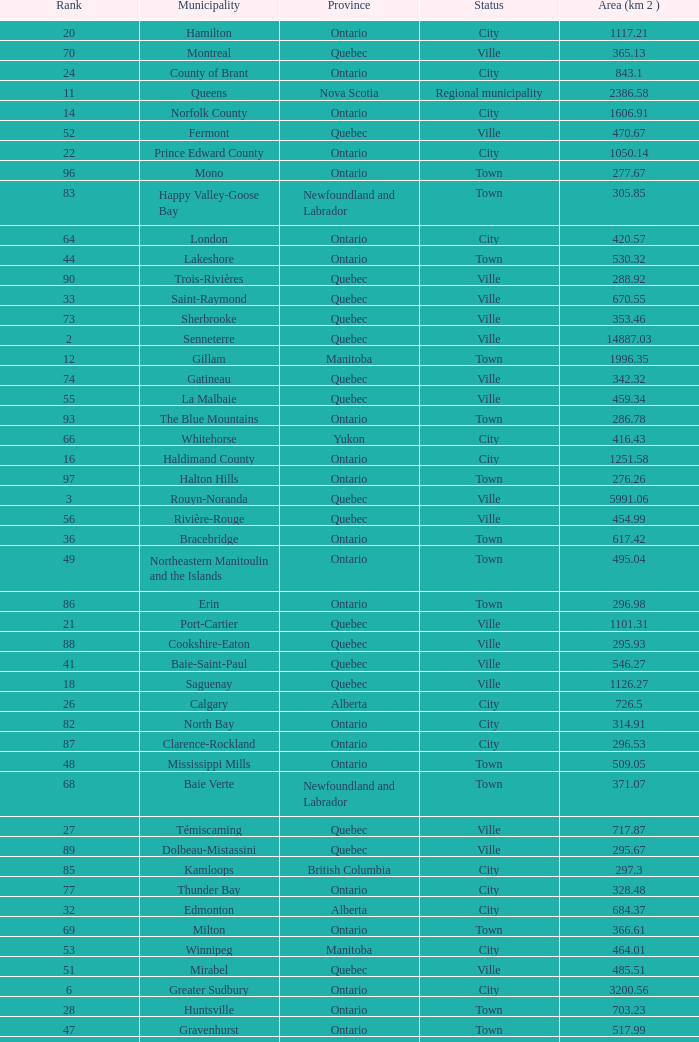What's the total of Rank that has an Area (KM 2) of 1050.14? 22.0. 